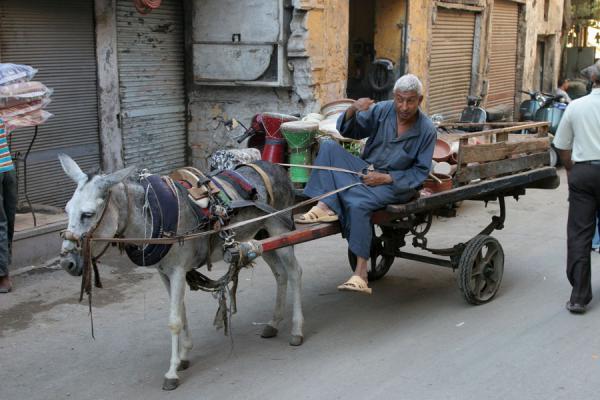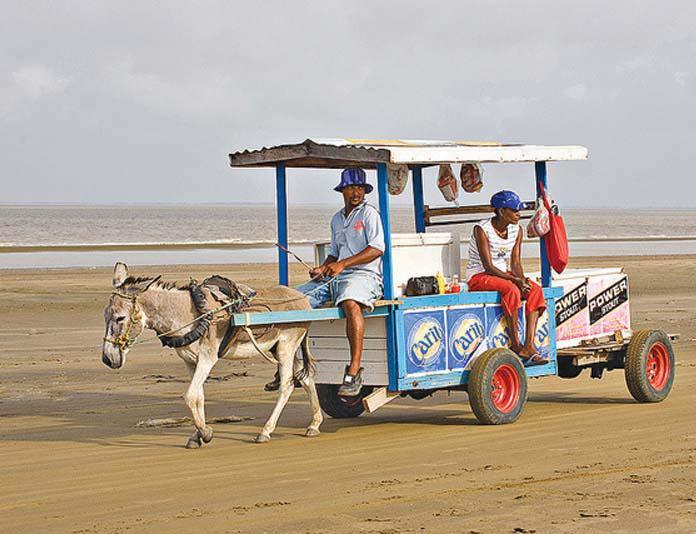The first image is the image on the left, the second image is the image on the right. Considering the images on both sides, is "The left and right image contains the same number of mules pulling a cart with at least on being a donkey." valid? Answer yes or no. Yes. The first image is the image on the left, the second image is the image on the right. For the images displayed, is the sentence "The right image shows one animal pulling a wagon with four wheels in a leftward direction." factually correct? Answer yes or no. Yes. 